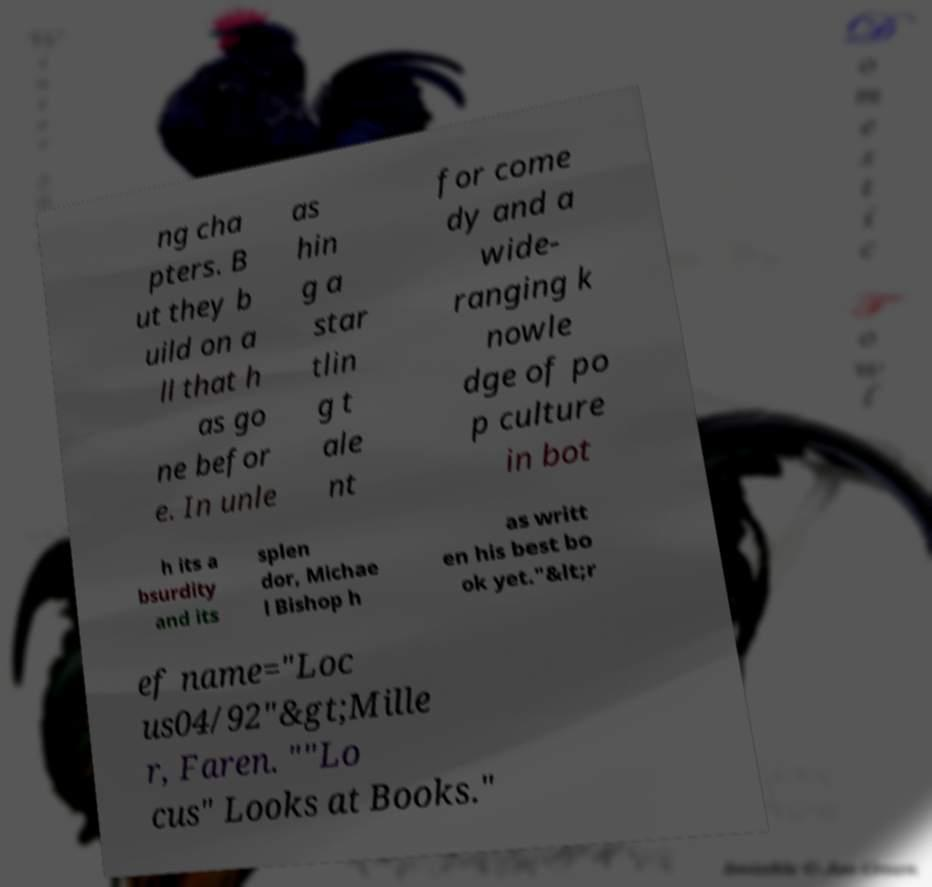I need the written content from this picture converted into text. Can you do that? ng cha pters. B ut they b uild on a ll that h as go ne befor e. In unle as hin g a star tlin g t ale nt for come dy and a wide- ranging k nowle dge of po p culture in bot h its a bsurdity and its splen dor, Michae l Bishop h as writt en his best bo ok yet."&lt;r ef name="Loc us04/92"&gt;Mille r, Faren. ""Lo cus" Looks at Books." 